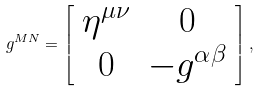Convert formula to latex. <formula><loc_0><loc_0><loc_500><loc_500>g ^ { M N } = \left [ \begin{array} { c c } \eta ^ { \mu \nu } & 0 \\ 0 & - g ^ { \alpha \beta } \end{array} \right ] ,</formula> 